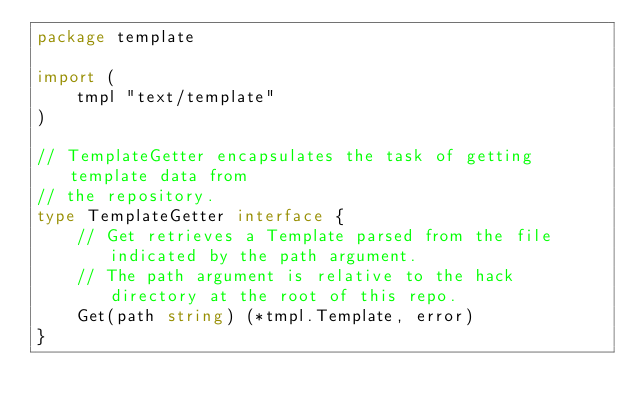Convert code to text. <code><loc_0><loc_0><loc_500><loc_500><_Go_>package template

import (
	tmpl "text/template"
)

// TemplateGetter encapsulates the task of getting template data from
// the repository.
type TemplateGetter interface {
	// Get retrieves a Template parsed from the file indicated by the path argument.
	// The path argument is relative to the hack directory at the root of this repo.
	Get(path string) (*tmpl.Template, error)
}
</code> 